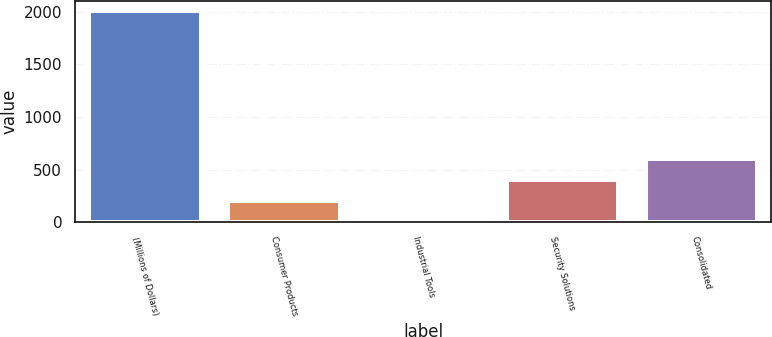Convert chart. <chart><loc_0><loc_0><loc_500><loc_500><bar_chart><fcel>(Millions of Dollars)<fcel>Consumer Products<fcel>Industrial Tools<fcel>Security Solutions<fcel>Consolidated<nl><fcel>2003<fcel>201.65<fcel>1.5<fcel>401.8<fcel>601.95<nl></chart> 